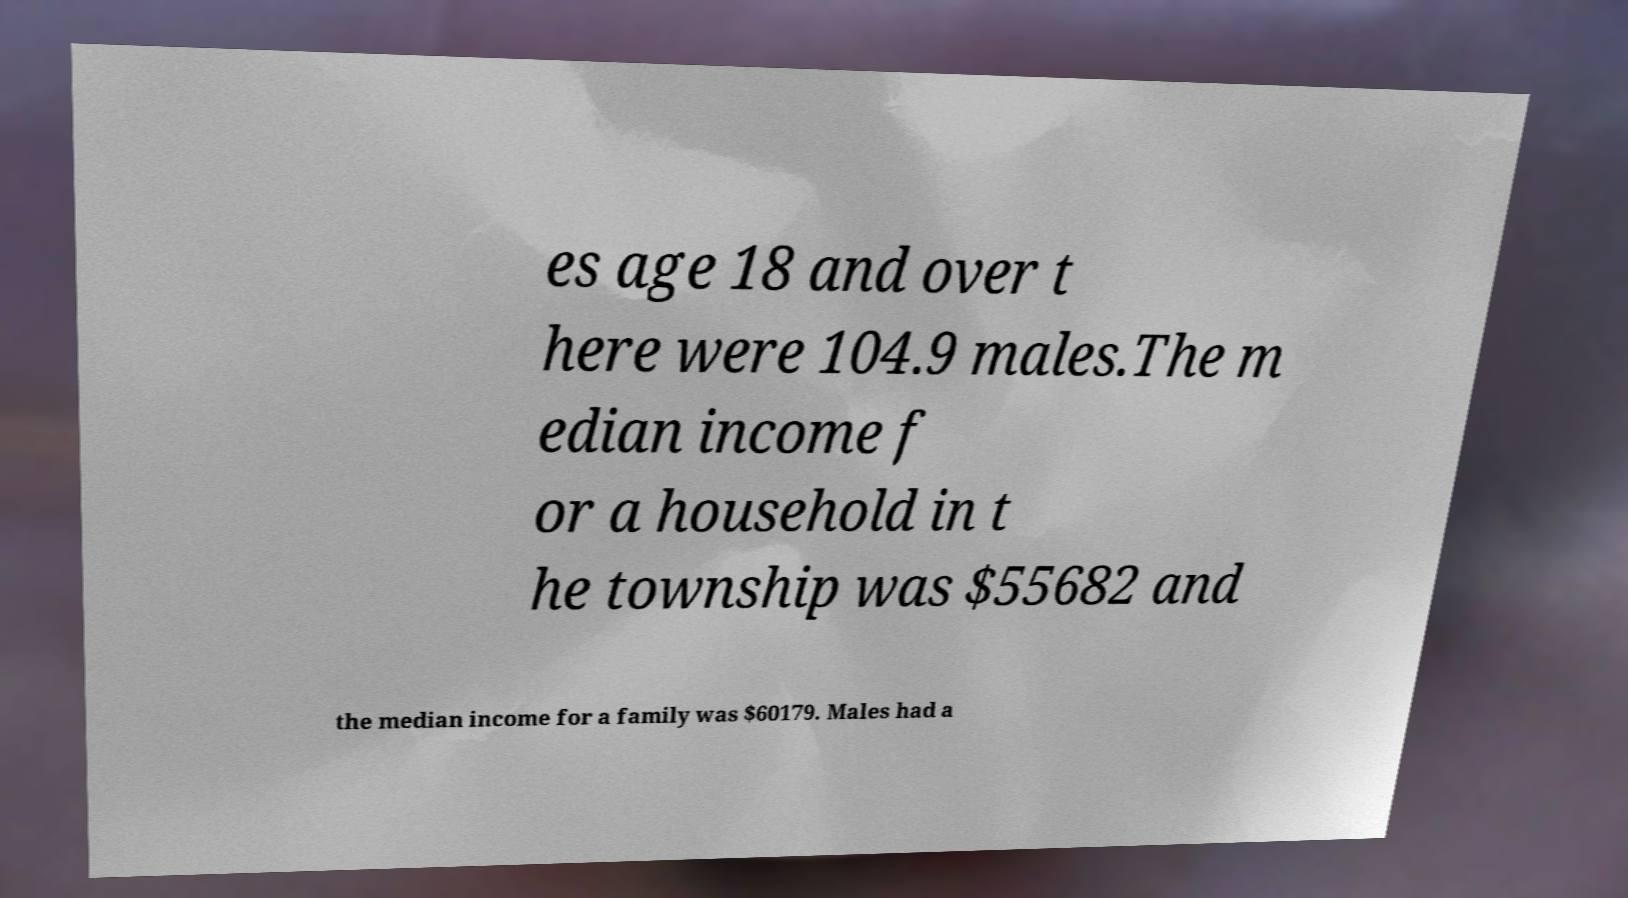Could you extract and type out the text from this image? es age 18 and over t here were 104.9 males.The m edian income f or a household in t he township was $55682 and the median income for a family was $60179. Males had a 